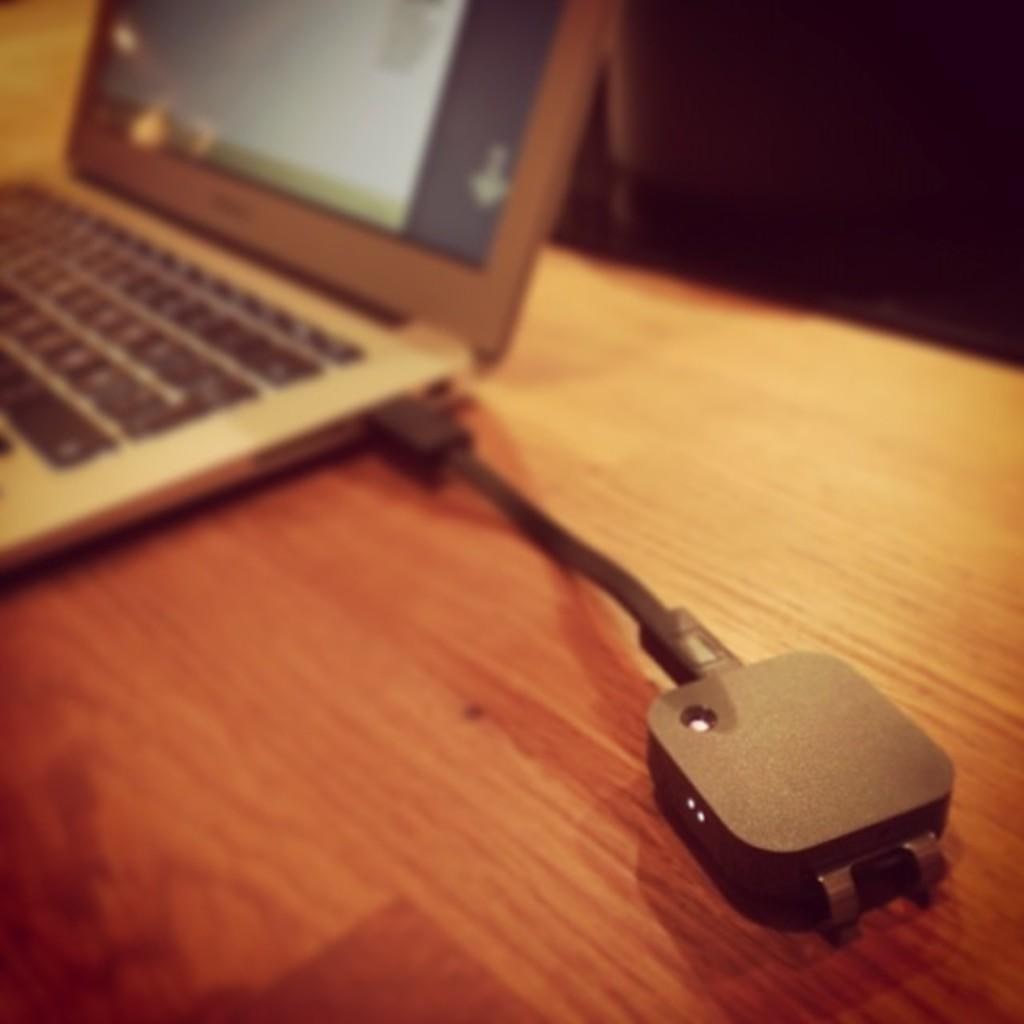What electronic device is visible in the image? There is a laptop in the image. What accessory is present for the laptop? There is a charger adapter in the image. Where are the laptop and charger adapter located? Both the laptop and charger adapter are on a table. What type of skirt is being worn by the laptop in the image? There is no skirt present in the image, as the laptop is an electronic device and not a person or living being. 